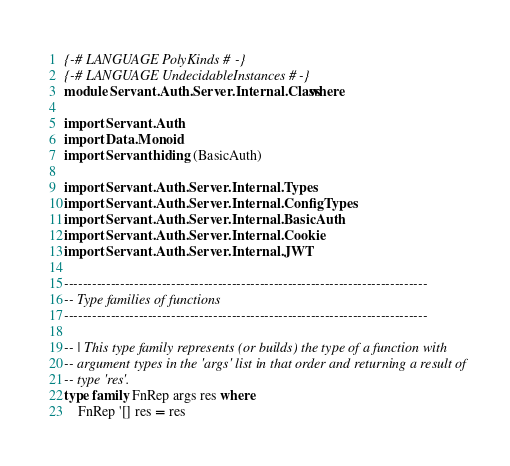<code> <loc_0><loc_0><loc_500><loc_500><_Haskell_>{-# LANGUAGE PolyKinds #-}
{-# LANGUAGE UndecidableInstances #-}
module Servant.Auth.Server.Internal.Class where

import Servant.Auth
import Data.Monoid
import Servant hiding (BasicAuth)

import Servant.Auth.Server.Internal.Types
import Servant.Auth.Server.Internal.ConfigTypes
import Servant.Auth.Server.Internal.BasicAuth
import Servant.Auth.Server.Internal.Cookie
import Servant.Auth.Server.Internal.JWT

------------------------------------------------------------------------------
-- Type families of functions
------------------------------------------------------------------------------

-- | This type family represents (or builds) the type of a function with
-- argument types in the 'args' list in that order and returning a result of
-- type 'res'.
type family FnRep args res where
    FnRep '[] res = res</code> 